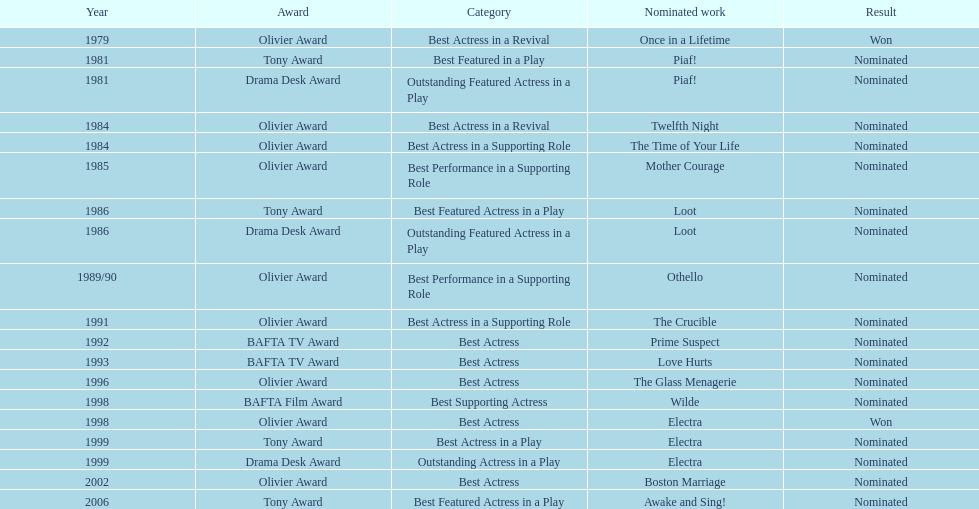Which play garnered wanamaker a nomination for outstanding featured actress? Piaf!. In what year did wanamaker participate in the play "once in a lifetime"? 1979. For which play in 1984 was wanamaker nominated for best actress? Twelfth Night. 